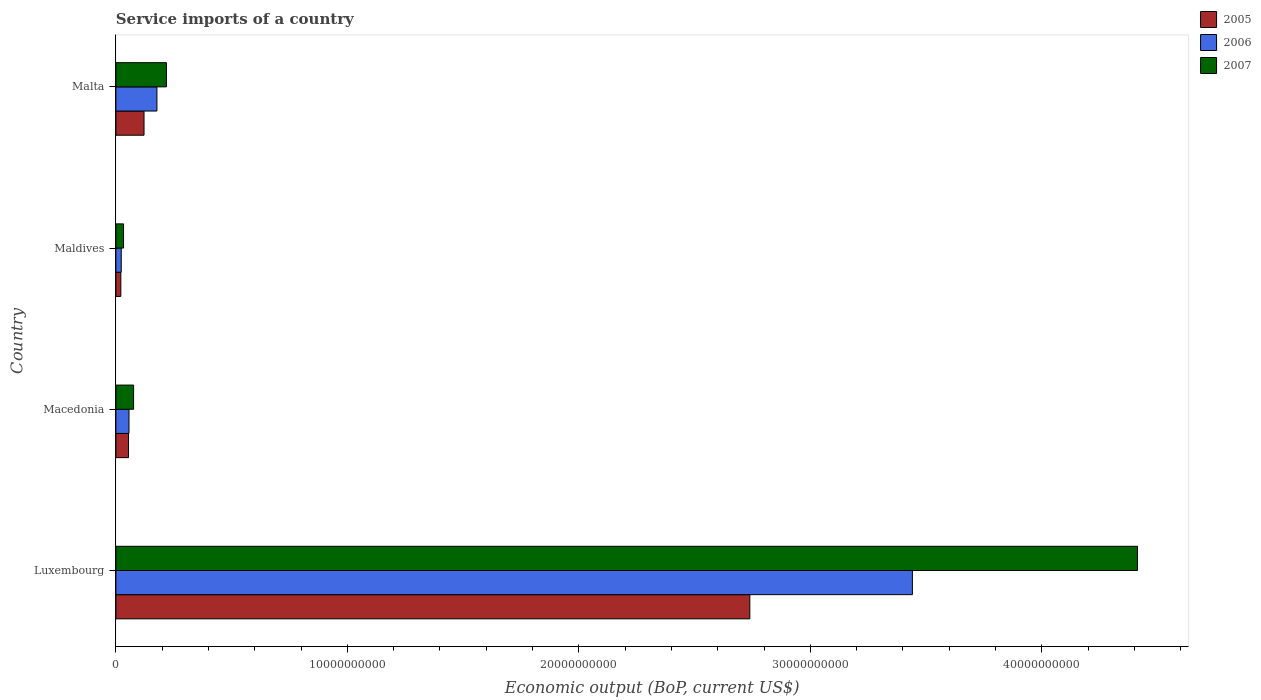How many groups of bars are there?
Give a very brief answer. 4. Are the number of bars per tick equal to the number of legend labels?
Your answer should be compact. Yes. How many bars are there on the 4th tick from the top?
Your answer should be very brief. 3. What is the label of the 3rd group of bars from the top?
Your answer should be very brief. Macedonia. In how many cases, is the number of bars for a given country not equal to the number of legend labels?
Offer a terse response. 0. What is the service imports in 2006 in Maldives?
Keep it short and to the point. 2.31e+08. Across all countries, what is the maximum service imports in 2005?
Your response must be concise. 2.74e+1. Across all countries, what is the minimum service imports in 2007?
Provide a succinct answer. 3.31e+08. In which country was the service imports in 2007 maximum?
Provide a short and direct response. Luxembourg. In which country was the service imports in 2006 minimum?
Offer a very short reply. Maldives. What is the total service imports in 2005 in the graph?
Provide a succinct answer. 2.94e+1. What is the difference between the service imports in 2005 in Luxembourg and that in Maldives?
Offer a very short reply. 2.72e+1. What is the difference between the service imports in 2007 in Luxembourg and the service imports in 2006 in Maldives?
Offer a terse response. 4.39e+1. What is the average service imports in 2005 per country?
Make the answer very short. 7.34e+09. What is the difference between the service imports in 2006 and service imports in 2007 in Malta?
Your answer should be very brief. -4.10e+08. What is the ratio of the service imports in 2005 in Luxembourg to that in Maldives?
Give a very brief answer. 128.53. Is the service imports in 2005 in Luxembourg less than that in Maldives?
Give a very brief answer. No. What is the difference between the highest and the second highest service imports in 2007?
Offer a very short reply. 4.19e+1. What is the difference between the highest and the lowest service imports in 2007?
Keep it short and to the point. 4.38e+1. What does the 3rd bar from the top in Luxembourg represents?
Make the answer very short. 2005. What does the 3rd bar from the bottom in Maldives represents?
Make the answer very short. 2007. How many countries are there in the graph?
Your response must be concise. 4. What is the difference between two consecutive major ticks on the X-axis?
Keep it short and to the point. 1.00e+1. Are the values on the major ticks of X-axis written in scientific E-notation?
Keep it short and to the point. No. Does the graph contain grids?
Your answer should be compact. No. Where does the legend appear in the graph?
Your answer should be very brief. Top right. How many legend labels are there?
Offer a terse response. 3. How are the legend labels stacked?
Your response must be concise. Vertical. What is the title of the graph?
Your answer should be very brief. Service imports of a country. Does "1988" appear as one of the legend labels in the graph?
Make the answer very short. No. What is the label or title of the X-axis?
Your answer should be very brief. Economic output (BoP, current US$). What is the Economic output (BoP, current US$) of 2005 in Luxembourg?
Offer a very short reply. 2.74e+1. What is the Economic output (BoP, current US$) of 2006 in Luxembourg?
Offer a terse response. 3.44e+1. What is the Economic output (BoP, current US$) of 2007 in Luxembourg?
Your answer should be very brief. 4.41e+1. What is the Economic output (BoP, current US$) in 2005 in Macedonia?
Give a very brief answer. 5.45e+08. What is the Economic output (BoP, current US$) in 2006 in Macedonia?
Your answer should be very brief. 5.66e+08. What is the Economic output (BoP, current US$) in 2007 in Macedonia?
Your response must be concise. 7.66e+08. What is the Economic output (BoP, current US$) of 2005 in Maldives?
Your answer should be compact. 2.13e+08. What is the Economic output (BoP, current US$) of 2006 in Maldives?
Provide a succinct answer. 2.31e+08. What is the Economic output (BoP, current US$) of 2007 in Maldives?
Ensure brevity in your answer.  3.31e+08. What is the Economic output (BoP, current US$) in 2005 in Malta?
Your answer should be compact. 1.22e+09. What is the Economic output (BoP, current US$) of 2006 in Malta?
Provide a short and direct response. 1.77e+09. What is the Economic output (BoP, current US$) in 2007 in Malta?
Keep it short and to the point. 2.18e+09. Across all countries, what is the maximum Economic output (BoP, current US$) in 2005?
Provide a succinct answer. 2.74e+1. Across all countries, what is the maximum Economic output (BoP, current US$) of 2006?
Your answer should be compact. 3.44e+1. Across all countries, what is the maximum Economic output (BoP, current US$) of 2007?
Offer a terse response. 4.41e+1. Across all countries, what is the minimum Economic output (BoP, current US$) in 2005?
Provide a succinct answer. 2.13e+08. Across all countries, what is the minimum Economic output (BoP, current US$) in 2006?
Your answer should be compact. 2.31e+08. Across all countries, what is the minimum Economic output (BoP, current US$) of 2007?
Provide a succinct answer. 3.31e+08. What is the total Economic output (BoP, current US$) in 2005 in the graph?
Make the answer very short. 2.94e+1. What is the total Economic output (BoP, current US$) in 2006 in the graph?
Give a very brief answer. 3.70e+1. What is the total Economic output (BoP, current US$) of 2007 in the graph?
Ensure brevity in your answer.  4.74e+1. What is the difference between the Economic output (BoP, current US$) of 2005 in Luxembourg and that in Macedonia?
Give a very brief answer. 2.68e+1. What is the difference between the Economic output (BoP, current US$) in 2006 in Luxembourg and that in Macedonia?
Keep it short and to the point. 3.38e+1. What is the difference between the Economic output (BoP, current US$) of 2007 in Luxembourg and that in Macedonia?
Offer a terse response. 4.34e+1. What is the difference between the Economic output (BoP, current US$) of 2005 in Luxembourg and that in Maldives?
Your response must be concise. 2.72e+1. What is the difference between the Economic output (BoP, current US$) in 2006 in Luxembourg and that in Maldives?
Provide a short and direct response. 3.42e+1. What is the difference between the Economic output (BoP, current US$) of 2007 in Luxembourg and that in Maldives?
Give a very brief answer. 4.38e+1. What is the difference between the Economic output (BoP, current US$) in 2005 in Luxembourg and that in Malta?
Give a very brief answer. 2.62e+1. What is the difference between the Economic output (BoP, current US$) in 2006 in Luxembourg and that in Malta?
Keep it short and to the point. 3.26e+1. What is the difference between the Economic output (BoP, current US$) in 2007 in Luxembourg and that in Malta?
Your answer should be very brief. 4.19e+1. What is the difference between the Economic output (BoP, current US$) in 2005 in Macedonia and that in Maldives?
Your answer should be compact. 3.32e+08. What is the difference between the Economic output (BoP, current US$) of 2006 in Macedonia and that in Maldives?
Your answer should be compact. 3.35e+08. What is the difference between the Economic output (BoP, current US$) in 2007 in Macedonia and that in Maldives?
Offer a very short reply. 4.35e+08. What is the difference between the Economic output (BoP, current US$) in 2005 in Macedonia and that in Malta?
Keep it short and to the point. -6.70e+08. What is the difference between the Economic output (BoP, current US$) of 2006 in Macedonia and that in Malta?
Give a very brief answer. -1.21e+09. What is the difference between the Economic output (BoP, current US$) in 2007 in Macedonia and that in Malta?
Give a very brief answer. -1.42e+09. What is the difference between the Economic output (BoP, current US$) in 2005 in Maldives and that in Malta?
Ensure brevity in your answer.  -1.00e+09. What is the difference between the Economic output (BoP, current US$) of 2006 in Maldives and that in Malta?
Make the answer very short. -1.54e+09. What is the difference between the Economic output (BoP, current US$) in 2007 in Maldives and that in Malta?
Offer a terse response. -1.85e+09. What is the difference between the Economic output (BoP, current US$) of 2005 in Luxembourg and the Economic output (BoP, current US$) of 2006 in Macedonia?
Offer a terse response. 2.68e+1. What is the difference between the Economic output (BoP, current US$) of 2005 in Luxembourg and the Economic output (BoP, current US$) of 2007 in Macedonia?
Your answer should be compact. 2.66e+1. What is the difference between the Economic output (BoP, current US$) in 2006 in Luxembourg and the Economic output (BoP, current US$) in 2007 in Macedonia?
Ensure brevity in your answer.  3.36e+1. What is the difference between the Economic output (BoP, current US$) in 2005 in Luxembourg and the Economic output (BoP, current US$) in 2006 in Maldives?
Your answer should be very brief. 2.72e+1. What is the difference between the Economic output (BoP, current US$) of 2005 in Luxembourg and the Economic output (BoP, current US$) of 2007 in Maldives?
Your answer should be very brief. 2.71e+1. What is the difference between the Economic output (BoP, current US$) of 2006 in Luxembourg and the Economic output (BoP, current US$) of 2007 in Maldives?
Give a very brief answer. 3.41e+1. What is the difference between the Economic output (BoP, current US$) of 2005 in Luxembourg and the Economic output (BoP, current US$) of 2006 in Malta?
Your response must be concise. 2.56e+1. What is the difference between the Economic output (BoP, current US$) of 2005 in Luxembourg and the Economic output (BoP, current US$) of 2007 in Malta?
Give a very brief answer. 2.52e+1. What is the difference between the Economic output (BoP, current US$) of 2006 in Luxembourg and the Economic output (BoP, current US$) of 2007 in Malta?
Keep it short and to the point. 3.22e+1. What is the difference between the Economic output (BoP, current US$) in 2005 in Macedonia and the Economic output (BoP, current US$) in 2006 in Maldives?
Give a very brief answer. 3.14e+08. What is the difference between the Economic output (BoP, current US$) in 2005 in Macedonia and the Economic output (BoP, current US$) in 2007 in Maldives?
Your answer should be very brief. 2.14e+08. What is the difference between the Economic output (BoP, current US$) in 2006 in Macedonia and the Economic output (BoP, current US$) in 2007 in Maldives?
Offer a terse response. 2.35e+08. What is the difference between the Economic output (BoP, current US$) in 2005 in Macedonia and the Economic output (BoP, current US$) in 2006 in Malta?
Provide a short and direct response. -1.23e+09. What is the difference between the Economic output (BoP, current US$) of 2005 in Macedonia and the Economic output (BoP, current US$) of 2007 in Malta?
Offer a terse response. -1.64e+09. What is the difference between the Economic output (BoP, current US$) in 2006 in Macedonia and the Economic output (BoP, current US$) in 2007 in Malta?
Your answer should be compact. -1.62e+09. What is the difference between the Economic output (BoP, current US$) in 2005 in Maldives and the Economic output (BoP, current US$) in 2006 in Malta?
Provide a short and direct response. -1.56e+09. What is the difference between the Economic output (BoP, current US$) of 2005 in Maldives and the Economic output (BoP, current US$) of 2007 in Malta?
Give a very brief answer. -1.97e+09. What is the difference between the Economic output (BoP, current US$) in 2006 in Maldives and the Economic output (BoP, current US$) in 2007 in Malta?
Your response must be concise. -1.95e+09. What is the average Economic output (BoP, current US$) in 2005 per country?
Offer a terse response. 7.34e+09. What is the average Economic output (BoP, current US$) in 2006 per country?
Keep it short and to the point. 9.24e+09. What is the average Economic output (BoP, current US$) in 2007 per country?
Your answer should be very brief. 1.19e+1. What is the difference between the Economic output (BoP, current US$) of 2005 and Economic output (BoP, current US$) of 2006 in Luxembourg?
Make the answer very short. -7.02e+09. What is the difference between the Economic output (BoP, current US$) of 2005 and Economic output (BoP, current US$) of 2007 in Luxembourg?
Provide a succinct answer. -1.67e+1. What is the difference between the Economic output (BoP, current US$) in 2006 and Economic output (BoP, current US$) in 2007 in Luxembourg?
Your answer should be compact. -9.72e+09. What is the difference between the Economic output (BoP, current US$) of 2005 and Economic output (BoP, current US$) of 2006 in Macedonia?
Offer a terse response. -2.10e+07. What is the difference between the Economic output (BoP, current US$) in 2005 and Economic output (BoP, current US$) in 2007 in Macedonia?
Provide a short and direct response. -2.21e+08. What is the difference between the Economic output (BoP, current US$) of 2006 and Economic output (BoP, current US$) of 2007 in Macedonia?
Keep it short and to the point. -2.00e+08. What is the difference between the Economic output (BoP, current US$) of 2005 and Economic output (BoP, current US$) of 2006 in Maldives?
Ensure brevity in your answer.  -1.81e+07. What is the difference between the Economic output (BoP, current US$) in 2005 and Economic output (BoP, current US$) in 2007 in Maldives?
Your answer should be very brief. -1.18e+08. What is the difference between the Economic output (BoP, current US$) of 2006 and Economic output (BoP, current US$) of 2007 in Maldives?
Your response must be concise. -9.97e+07. What is the difference between the Economic output (BoP, current US$) of 2005 and Economic output (BoP, current US$) of 2006 in Malta?
Your response must be concise. -5.57e+08. What is the difference between the Economic output (BoP, current US$) in 2005 and Economic output (BoP, current US$) in 2007 in Malta?
Give a very brief answer. -9.67e+08. What is the difference between the Economic output (BoP, current US$) in 2006 and Economic output (BoP, current US$) in 2007 in Malta?
Your response must be concise. -4.10e+08. What is the ratio of the Economic output (BoP, current US$) in 2005 in Luxembourg to that in Macedonia?
Give a very brief answer. 50.23. What is the ratio of the Economic output (BoP, current US$) of 2006 in Luxembourg to that in Macedonia?
Give a very brief answer. 60.77. What is the ratio of the Economic output (BoP, current US$) of 2007 in Luxembourg to that in Macedonia?
Ensure brevity in your answer.  57.64. What is the ratio of the Economic output (BoP, current US$) in 2005 in Luxembourg to that in Maldives?
Your answer should be very brief. 128.53. What is the ratio of the Economic output (BoP, current US$) in 2006 in Luxembourg to that in Maldives?
Provide a short and direct response. 148.84. What is the ratio of the Economic output (BoP, current US$) in 2007 in Luxembourg to that in Maldives?
Keep it short and to the point. 133.37. What is the ratio of the Economic output (BoP, current US$) of 2005 in Luxembourg to that in Malta?
Your answer should be very brief. 22.53. What is the ratio of the Economic output (BoP, current US$) in 2006 in Luxembourg to that in Malta?
Your answer should be very brief. 19.41. What is the ratio of the Economic output (BoP, current US$) of 2007 in Luxembourg to that in Malta?
Your answer should be compact. 20.22. What is the ratio of the Economic output (BoP, current US$) of 2005 in Macedonia to that in Maldives?
Give a very brief answer. 2.56. What is the ratio of the Economic output (BoP, current US$) of 2006 in Macedonia to that in Maldives?
Your answer should be very brief. 2.45. What is the ratio of the Economic output (BoP, current US$) of 2007 in Macedonia to that in Maldives?
Provide a succinct answer. 2.31. What is the ratio of the Economic output (BoP, current US$) of 2005 in Macedonia to that in Malta?
Your response must be concise. 0.45. What is the ratio of the Economic output (BoP, current US$) of 2006 in Macedonia to that in Malta?
Make the answer very short. 0.32. What is the ratio of the Economic output (BoP, current US$) in 2007 in Macedonia to that in Malta?
Provide a succinct answer. 0.35. What is the ratio of the Economic output (BoP, current US$) of 2005 in Maldives to that in Malta?
Your answer should be very brief. 0.18. What is the ratio of the Economic output (BoP, current US$) of 2006 in Maldives to that in Malta?
Keep it short and to the point. 0.13. What is the ratio of the Economic output (BoP, current US$) in 2007 in Maldives to that in Malta?
Your answer should be very brief. 0.15. What is the difference between the highest and the second highest Economic output (BoP, current US$) of 2005?
Your response must be concise. 2.62e+1. What is the difference between the highest and the second highest Economic output (BoP, current US$) of 2006?
Your answer should be compact. 3.26e+1. What is the difference between the highest and the second highest Economic output (BoP, current US$) in 2007?
Give a very brief answer. 4.19e+1. What is the difference between the highest and the lowest Economic output (BoP, current US$) of 2005?
Provide a succinct answer. 2.72e+1. What is the difference between the highest and the lowest Economic output (BoP, current US$) in 2006?
Make the answer very short. 3.42e+1. What is the difference between the highest and the lowest Economic output (BoP, current US$) in 2007?
Offer a terse response. 4.38e+1. 